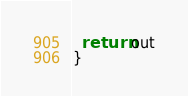Convert code to text. <code><loc_0><loc_0><loc_500><loc_500><_JavaScript_>  return out
}
</code> 